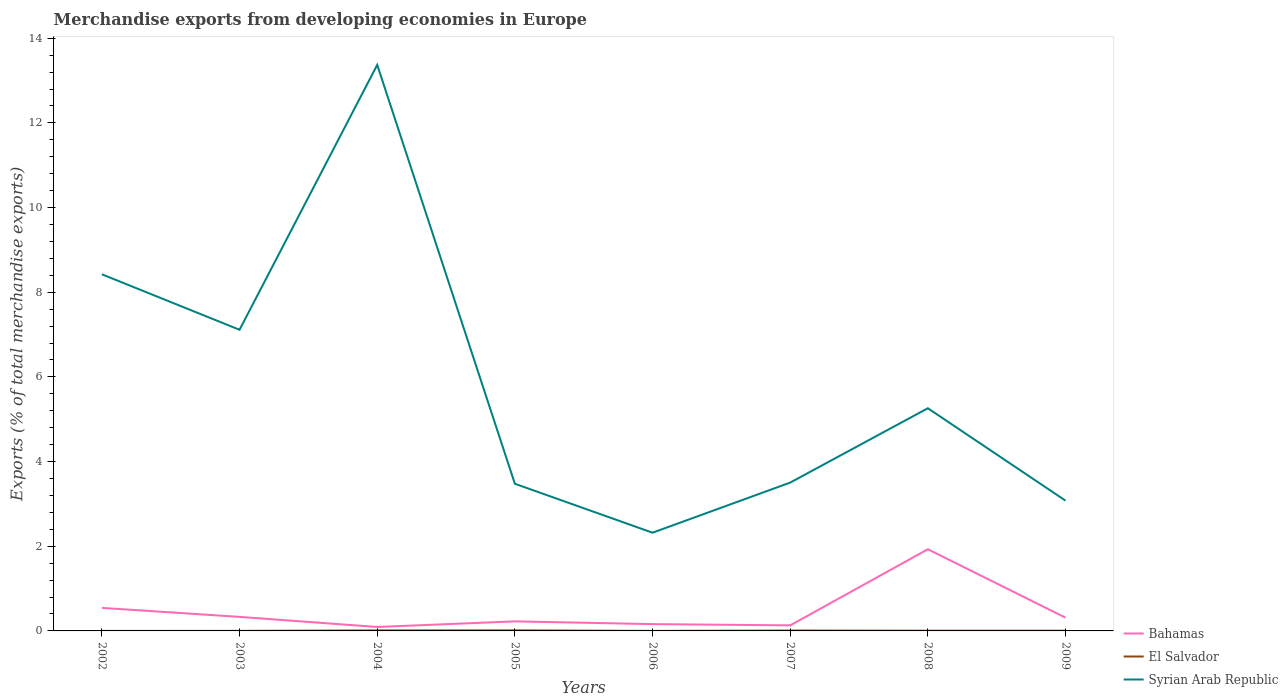How many different coloured lines are there?
Provide a succinct answer. 3. Does the line corresponding to Bahamas intersect with the line corresponding to Syrian Arab Republic?
Provide a short and direct response. No. Across all years, what is the maximum percentage of total merchandise exports in El Salvador?
Ensure brevity in your answer.  0. In which year was the percentage of total merchandise exports in Syrian Arab Republic maximum?
Your answer should be very brief. 2006. What is the total percentage of total merchandise exports in Syrian Arab Republic in the graph?
Keep it short and to the point. -1.78. What is the difference between the highest and the second highest percentage of total merchandise exports in Syrian Arab Republic?
Keep it short and to the point. 11.05. What is the difference between the highest and the lowest percentage of total merchandise exports in Bahamas?
Give a very brief answer. 2. Is the percentage of total merchandise exports in Syrian Arab Republic strictly greater than the percentage of total merchandise exports in Bahamas over the years?
Offer a terse response. No. How many years are there in the graph?
Keep it short and to the point. 8. Does the graph contain any zero values?
Offer a terse response. No. What is the title of the graph?
Make the answer very short. Merchandise exports from developing economies in Europe. Does "Middle East & North Africa (all income levels)" appear as one of the legend labels in the graph?
Give a very brief answer. No. What is the label or title of the Y-axis?
Give a very brief answer. Exports (% of total merchandise exports). What is the Exports (% of total merchandise exports) of Bahamas in 2002?
Your response must be concise. 0.54. What is the Exports (% of total merchandise exports) of El Salvador in 2002?
Your response must be concise. 0. What is the Exports (% of total merchandise exports) of Syrian Arab Republic in 2002?
Your answer should be very brief. 8.42. What is the Exports (% of total merchandise exports) in Bahamas in 2003?
Your response must be concise. 0.33. What is the Exports (% of total merchandise exports) of El Salvador in 2003?
Provide a short and direct response. 0. What is the Exports (% of total merchandise exports) of Syrian Arab Republic in 2003?
Provide a short and direct response. 7.11. What is the Exports (% of total merchandise exports) in Bahamas in 2004?
Keep it short and to the point. 0.09. What is the Exports (% of total merchandise exports) of El Salvador in 2004?
Your answer should be compact. 0.01. What is the Exports (% of total merchandise exports) of Syrian Arab Republic in 2004?
Provide a short and direct response. 13.37. What is the Exports (% of total merchandise exports) of Bahamas in 2005?
Your answer should be compact. 0.23. What is the Exports (% of total merchandise exports) in El Salvador in 2005?
Provide a short and direct response. 0.01. What is the Exports (% of total merchandise exports) of Syrian Arab Republic in 2005?
Offer a terse response. 3.48. What is the Exports (% of total merchandise exports) of Bahamas in 2006?
Keep it short and to the point. 0.16. What is the Exports (% of total merchandise exports) of El Salvador in 2006?
Provide a succinct answer. 0. What is the Exports (% of total merchandise exports) in Syrian Arab Republic in 2006?
Your answer should be compact. 2.32. What is the Exports (% of total merchandise exports) of Bahamas in 2007?
Keep it short and to the point. 0.13. What is the Exports (% of total merchandise exports) of El Salvador in 2007?
Offer a terse response. 0.01. What is the Exports (% of total merchandise exports) in Syrian Arab Republic in 2007?
Give a very brief answer. 3.5. What is the Exports (% of total merchandise exports) of Bahamas in 2008?
Make the answer very short. 1.93. What is the Exports (% of total merchandise exports) of El Salvador in 2008?
Offer a very short reply. 0. What is the Exports (% of total merchandise exports) of Syrian Arab Republic in 2008?
Offer a terse response. 5.26. What is the Exports (% of total merchandise exports) of Bahamas in 2009?
Keep it short and to the point. 0.31. What is the Exports (% of total merchandise exports) of El Salvador in 2009?
Your response must be concise. 0. What is the Exports (% of total merchandise exports) in Syrian Arab Republic in 2009?
Your answer should be very brief. 3.08. Across all years, what is the maximum Exports (% of total merchandise exports) in Bahamas?
Offer a very short reply. 1.93. Across all years, what is the maximum Exports (% of total merchandise exports) of El Salvador?
Offer a terse response. 0.01. Across all years, what is the maximum Exports (% of total merchandise exports) in Syrian Arab Republic?
Ensure brevity in your answer.  13.37. Across all years, what is the minimum Exports (% of total merchandise exports) in Bahamas?
Provide a succinct answer. 0.09. Across all years, what is the minimum Exports (% of total merchandise exports) of El Salvador?
Offer a very short reply. 0. Across all years, what is the minimum Exports (% of total merchandise exports) of Syrian Arab Republic?
Ensure brevity in your answer.  2.32. What is the total Exports (% of total merchandise exports) of Bahamas in the graph?
Keep it short and to the point. 3.73. What is the total Exports (% of total merchandise exports) of El Salvador in the graph?
Provide a succinct answer. 0.05. What is the total Exports (% of total merchandise exports) of Syrian Arab Republic in the graph?
Your answer should be compact. 46.55. What is the difference between the Exports (% of total merchandise exports) of Bahamas in 2002 and that in 2003?
Your response must be concise. 0.21. What is the difference between the Exports (% of total merchandise exports) in El Salvador in 2002 and that in 2003?
Provide a short and direct response. -0. What is the difference between the Exports (% of total merchandise exports) of Syrian Arab Republic in 2002 and that in 2003?
Provide a succinct answer. 1.31. What is the difference between the Exports (% of total merchandise exports) of Bahamas in 2002 and that in 2004?
Provide a short and direct response. 0.45. What is the difference between the Exports (% of total merchandise exports) of El Salvador in 2002 and that in 2004?
Make the answer very short. -0.01. What is the difference between the Exports (% of total merchandise exports) of Syrian Arab Republic in 2002 and that in 2004?
Keep it short and to the point. -4.95. What is the difference between the Exports (% of total merchandise exports) of Bahamas in 2002 and that in 2005?
Offer a terse response. 0.32. What is the difference between the Exports (% of total merchandise exports) of El Salvador in 2002 and that in 2005?
Provide a succinct answer. -0.01. What is the difference between the Exports (% of total merchandise exports) of Syrian Arab Republic in 2002 and that in 2005?
Your response must be concise. 4.95. What is the difference between the Exports (% of total merchandise exports) in Bahamas in 2002 and that in 2006?
Offer a very short reply. 0.38. What is the difference between the Exports (% of total merchandise exports) of Syrian Arab Republic in 2002 and that in 2006?
Your response must be concise. 6.1. What is the difference between the Exports (% of total merchandise exports) of Bahamas in 2002 and that in 2007?
Ensure brevity in your answer.  0.41. What is the difference between the Exports (% of total merchandise exports) of El Salvador in 2002 and that in 2007?
Ensure brevity in your answer.  -0.01. What is the difference between the Exports (% of total merchandise exports) in Syrian Arab Republic in 2002 and that in 2007?
Give a very brief answer. 4.92. What is the difference between the Exports (% of total merchandise exports) of Bahamas in 2002 and that in 2008?
Ensure brevity in your answer.  -1.38. What is the difference between the Exports (% of total merchandise exports) in El Salvador in 2002 and that in 2008?
Provide a succinct answer. -0. What is the difference between the Exports (% of total merchandise exports) in Syrian Arab Republic in 2002 and that in 2008?
Your answer should be very brief. 3.16. What is the difference between the Exports (% of total merchandise exports) in Bahamas in 2002 and that in 2009?
Your answer should be very brief. 0.23. What is the difference between the Exports (% of total merchandise exports) in El Salvador in 2002 and that in 2009?
Ensure brevity in your answer.  -0. What is the difference between the Exports (% of total merchandise exports) of Syrian Arab Republic in 2002 and that in 2009?
Your response must be concise. 5.35. What is the difference between the Exports (% of total merchandise exports) of Bahamas in 2003 and that in 2004?
Provide a succinct answer. 0.24. What is the difference between the Exports (% of total merchandise exports) in El Salvador in 2003 and that in 2004?
Give a very brief answer. -0.01. What is the difference between the Exports (% of total merchandise exports) of Syrian Arab Republic in 2003 and that in 2004?
Provide a succinct answer. -6.26. What is the difference between the Exports (% of total merchandise exports) of Bahamas in 2003 and that in 2005?
Ensure brevity in your answer.  0.11. What is the difference between the Exports (% of total merchandise exports) of El Salvador in 2003 and that in 2005?
Your answer should be very brief. -0.01. What is the difference between the Exports (% of total merchandise exports) of Syrian Arab Republic in 2003 and that in 2005?
Provide a succinct answer. 3.64. What is the difference between the Exports (% of total merchandise exports) in Bahamas in 2003 and that in 2006?
Give a very brief answer. 0.17. What is the difference between the Exports (% of total merchandise exports) in El Salvador in 2003 and that in 2006?
Make the answer very short. 0. What is the difference between the Exports (% of total merchandise exports) of Syrian Arab Republic in 2003 and that in 2006?
Make the answer very short. 4.79. What is the difference between the Exports (% of total merchandise exports) of Bahamas in 2003 and that in 2007?
Provide a succinct answer. 0.2. What is the difference between the Exports (% of total merchandise exports) in El Salvador in 2003 and that in 2007?
Your answer should be compact. -0.01. What is the difference between the Exports (% of total merchandise exports) of Syrian Arab Republic in 2003 and that in 2007?
Keep it short and to the point. 3.61. What is the difference between the Exports (% of total merchandise exports) in Bahamas in 2003 and that in 2008?
Your answer should be compact. -1.6. What is the difference between the Exports (% of total merchandise exports) of El Salvador in 2003 and that in 2008?
Provide a short and direct response. -0. What is the difference between the Exports (% of total merchandise exports) in Syrian Arab Republic in 2003 and that in 2008?
Your answer should be very brief. 1.85. What is the difference between the Exports (% of total merchandise exports) in Bahamas in 2003 and that in 2009?
Your answer should be very brief. 0.02. What is the difference between the Exports (% of total merchandise exports) of El Salvador in 2003 and that in 2009?
Provide a succinct answer. -0. What is the difference between the Exports (% of total merchandise exports) in Syrian Arab Republic in 2003 and that in 2009?
Provide a succinct answer. 4.04. What is the difference between the Exports (% of total merchandise exports) in Bahamas in 2004 and that in 2005?
Ensure brevity in your answer.  -0.13. What is the difference between the Exports (% of total merchandise exports) in El Salvador in 2004 and that in 2005?
Your answer should be very brief. -0. What is the difference between the Exports (% of total merchandise exports) in Syrian Arab Republic in 2004 and that in 2005?
Offer a very short reply. 9.89. What is the difference between the Exports (% of total merchandise exports) of Bahamas in 2004 and that in 2006?
Offer a terse response. -0.07. What is the difference between the Exports (% of total merchandise exports) of El Salvador in 2004 and that in 2006?
Provide a short and direct response. 0.01. What is the difference between the Exports (% of total merchandise exports) in Syrian Arab Republic in 2004 and that in 2006?
Provide a short and direct response. 11.05. What is the difference between the Exports (% of total merchandise exports) of Bahamas in 2004 and that in 2007?
Make the answer very short. -0.04. What is the difference between the Exports (% of total merchandise exports) of El Salvador in 2004 and that in 2007?
Your answer should be compact. 0. What is the difference between the Exports (% of total merchandise exports) in Syrian Arab Republic in 2004 and that in 2007?
Give a very brief answer. 9.87. What is the difference between the Exports (% of total merchandise exports) in Bahamas in 2004 and that in 2008?
Give a very brief answer. -1.84. What is the difference between the Exports (% of total merchandise exports) of El Salvador in 2004 and that in 2008?
Keep it short and to the point. 0.01. What is the difference between the Exports (% of total merchandise exports) of Syrian Arab Republic in 2004 and that in 2008?
Your answer should be very brief. 8.11. What is the difference between the Exports (% of total merchandise exports) of Bahamas in 2004 and that in 2009?
Offer a terse response. -0.22. What is the difference between the Exports (% of total merchandise exports) of El Salvador in 2004 and that in 2009?
Keep it short and to the point. 0.01. What is the difference between the Exports (% of total merchandise exports) in Syrian Arab Republic in 2004 and that in 2009?
Your response must be concise. 10.29. What is the difference between the Exports (% of total merchandise exports) in Bahamas in 2005 and that in 2006?
Your answer should be compact. 0.07. What is the difference between the Exports (% of total merchandise exports) of El Salvador in 2005 and that in 2006?
Keep it short and to the point. 0.01. What is the difference between the Exports (% of total merchandise exports) of Syrian Arab Republic in 2005 and that in 2006?
Ensure brevity in your answer.  1.16. What is the difference between the Exports (% of total merchandise exports) in Bahamas in 2005 and that in 2007?
Offer a terse response. 0.09. What is the difference between the Exports (% of total merchandise exports) of El Salvador in 2005 and that in 2007?
Your answer should be very brief. 0. What is the difference between the Exports (% of total merchandise exports) in Syrian Arab Republic in 2005 and that in 2007?
Keep it short and to the point. -0.03. What is the difference between the Exports (% of total merchandise exports) in Bahamas in 2005 and that in 2008?
Ensure brevity in your answer.  -1.7. What is the difference between the Exports (% of total merchandise exports) in El Salvador in 2005 and that in 2008?
Offer a terse response. 0.01. What is the difference between the Exports (% of total merchandise exports) of Syrian Arab Republic in 2005 and that in 2008?
Your answer should be compact. -1.78. What is the difference between the Exports (% of total merchandise exports) of Bahamas in 2005 and that in 2009?
Your answer should be compact. -0.09. What is the difference between the Exports (% of total merchandise exports) of El Salvador in 2005 and that in 2009?
Keep it short and to the point. 0.01. What is the difference between the Exports (% of total merchandise exports) of Syrian Arab Republic in 2005 and that in 2009?
Give a very brief answer. 0.4. What is the difference between the Exports (% of total merchandise exports) of Bahamas in 2006 and that in 2007?
Your answer should be very brief. 0.03. What is the difference between the Exports (% of total merchandise exports) of El Salvador in 2006 and that in 2007?
Your response must be concise. -0.01. What is the difference between the Exports (% of total merchandise exports) in Syrian Arab Republic in 2006 and that in 2007?
Provide a succinct answer. -1.18. What is the difference between the Exports (% of total merchandise exports) in Bahamas in 2006 and that in 2008?
Give a very brief answer. -1.77. What is the difference between the Exports (% of total merchandise exports) in El Salvador in 2006 and that in 2008?
Your answer should be very brief. -0. What is the difference between the Exports (% of total merchandise exports) in Syrian Arab Republic in 2006 and that in 2008?
Provide a short and direct response. -2.94. What is the difference between the Exports (% of total merchandise exports) in Bahamas in 2006 and that in 2009?
Provide a succinct answer. -0.15. What is the difference between the Exports (% of total merchandise exports) in El Salvador in 2006 and that in 2009?
Offer a terse response. -0. What is the difference between the Exports (% of total merchandise exports) in Syrian Arab Republic in 2006 and that in 2009?
Provide a short and direct response. -0.76. What is the difference between the Exports (% of total merchandise exports) in Bahamas in 2007 and that in 2008?
Keep it short and to the point. -1.8. What is the difference between the Exports (% of total merchandise exports) in El Salvador in 2007 and that in 2008?
Your response must be concise. 0. What is the difference between the Exports (% of total merchandise exports) in Syrian Arab Republic in 2007 and that in 2008?
Your answer should be very brief. -1.76. What is the difference between the Exports (% of total merchandise exports) of Bahamas in 2007 and that in 2009?
Provide a succinct answer. -0.18. What is the difference between the Exports (% of total merchandise exports) of El Salvador in 2007 and that in 2009?
Keep it short and to the point. 0. What is the difference between the Exports (% of total merchandise exports) in Syrian Arab Republic in 2007 and that in 2009?
Give a very brief answer. 0.43. What is the difference between the Exports (% of total merchandise exports) in Bahamas in 2008 and that in 2009?
Ensure brevity in your answer.  1.62. What is the difference between the Exports (% of total merchandise exports) of Syrian Arab Republic in 2008 and that in 2009?
Offer a terse response. 2.18. What is the difference between the Exports (% of total merchandise exports) of Bahamas in 2002 and the Exports (% of total merchandise exports) of El Salvador in 2003?
Your answer should be very brief. 0.54. What is the difference between the Exports (% of total merchandise exports) of Bahamas in 2002 and the Exports (% of total merchandise exports) of Syrian Arab Republic in 2003?
Your response must be concise. -6.57. What is the difference between the Exports (% of total merchandise exports) in El Salvador in 2002 and the Exports (% of total merchandise exports) in Syrian Arab Republic in 2003?
Offer a very short reply. -7.11. What is the difference between the Exports (% of total merchandise exports) in Bahamas in 2002 and the Exports (% of total merchandise exports) in El Salvador in 2004?
Your answer should be very brief. 0.53. What is the difference between the Exports (% of total merchandise exports) of Bahamas in 2002 and the Exports (% of total merchandise exports) of Syrian Arab Republic in 2004?
Make the answer very short. -12.83. What is the difference between the Exports (% of total merchandise exports) in El Salvador in 2002 and the Exports (% of total merchandise exports) in Syrian Arab Republic in 2004?
Give a very brief answer. -13.37. What is the difference between the Exports (% of total merchandise exports) of Bahamas in 2002 and the Exports (% of total merchandise exports) of El Salvador in 2005?
Offer a very short reply. 0.53. What is the difference between the Exports (% of total merchandise exports) in Bahamas in 2002 and the Exports (% of total merchandise exports) in Syrian Arab Republic in 2005?
Provide a succinct answer. -2.93. What is the difference between the Exports (% of total merchandise exports) of El Salvador in 2002 and the Exports (% of total merchandise exports) of Syrian Arab Republic in 2005?
Your answer should be compact. -3.48. What is the difference between the Exports (% of total merchandise exports) in Bahamas in 2002 and the Exports (% of total merchandise exports) in El Salvador in 2006?
Keep it short and to the point. 0.54. What is the difference between the Exports (% of total merchandise exports) of Bahamas in 2002 and the Exports (% of total merchandise exports) of Syrian Arab Republic in 2006?
Keep it short and to the point. -1.78. What is the difference between the Exports (% of total merchandise exports) of El Salvador in 2002 and the Exports (% of total merchandise exports) of Syrian Arab Republic in 2006?
Keep it short and to the point. -2.32. What is the difference between the Exports (% of total merchandise exports) in Bahamas in 2002 and the Exports (% of total merchandise exports) in El Salvador in 2007?
Offer a terse response. 0.54. What is the difference between the Exports (% of total merchandise exports) of Bahamas in 2002 and the Exports (% of total merchandise exports) of Syrian Arab Republic in 2007?
Offer a terse response. -2.96. What is the difference between the Exports (% of total merchandise exports) of El Salvador in 2002 and the Exports (% of total merchandise exports) of Syrian Arab Republic in 2007?
Provide a short and direct response. -3.5. What is the difference between the Exports (% of total merchandise exports) in Bahamas in 2002 and the Exports (% of total merchandise exports) in El Salvador in 2008?
Keep it short and to the point. 0.54. What is the difference between the Exports (% of total merchandise exports) in Bahamas in 2002 and the Exports (% of total merchandise exports) in Syrian Arab Republic in 2008?
Provide a succinct answer. -4.72. What is the difference between the Exports (% of total merchandise exports) of El Salvador in 2002 and the Exports (% of total merchandise exports) of Syrian Arab Republic in 2008?
Offer a very short reply. -5.26. What is the difference between the Exports (% of total merchandise exports) in Bahamas in 2002 and the Exports (% of total merchandise exports) in El Salvador in 2009?
Provide a short and direct response. 0.54. What is the difference between the Exports (% of total merchandise exports) of Bahamas in 2002 and the Exports (% of total merchandise exports) of Syrian Arab Republic in 2009?
Give a very brief answer. -2.53. What is the difference between the Exports (% of total merchandise exports) of El Salvador in 2002 and the Exports (% of total merchandise exports) of Syrian Arab Republic in 2009?
Make the answer very short. -3.08. What is the difference between the Exports (% of total merchandise exports) of Bahamas in 2003 and the Exports (% of total merchandise exports) of El Salvador in 2004?
Provide a succinct answer. 0.32. What is the difference between the Exports (% of total merchandise exports) of Bahamas in 2003 and the Exports (% of total merchandise exports) of Syrian Arab Republic in 2004?
Ensure brevity in your answer.  -13.04. What is the difference between the Exports (% of total merchandise exports) in El Salvador in 2003 and the Exports (% of total merchandise exports) in Syrian Arab Republic in 2004?
Offer a terse response. -13.37. What is the difference between the Exports (% of total merchandise exports) in Bahamas in 2003 and the Exports (% of total merchandise exports) in El Salvador in 2005?
Provide a short and direct response. 0.32. What is the difference between the Exports (% of total merchandise exports) of Bahamas in 2003 and the Exports (% of total merchandise exports) of Syrian Arab Republic in 2005?
Provide a short and direct response. -3.14. What is the difference between the Exports (% of total merchandise exports) in El Salvador in 2003 and the Exports (% of total merchandise exports) in Syrian Arab Republic in 2005?
Ensure brevity in your answer.  -3.48. What is the difference between the Exports (% of total merchandise exports) in Bahamas in 2003 and the Exports (% of total merchandise exports) in El Salvador in 2006?
Ensure brevity in your answer.  0.33. What is the difference between the Exports (% of total merchandise exports) of Bahamas in 2003 and the Exports (% of total merchandise exports) of Syrian Arab Republic in 2006?
Provide a succinct answer. -1.99. What is the difference between the Exports (% of total merchandise exports) of El Salvador in 2003 and the Exports (% of total merchandise exports) of Syrian Arab Republic in 2006?
Ensure brevity in your answer.  -2.32. What is the difference between the Exports (% of total merchandise exports) in Bahamas in 2003 and the Exports (% of total merchandise exports) in El Salvador in 2007?
Offer a very short reply. 0.32. What is the difference between the Exports (% of total merchandise exports) of Bahamas in 2003 and the Exports (% of total merchandise exports) of Syrian Arab Republic in 2007?
Offer a terse response. -3.17. What is the difference between the Exports (% of total merchandise exports) in El Salvador in 2003 and the Exports (% of total merchandise exports) in Syrian Arab Republic in 2007?
Give a very brief answer. -3.5. What is the difference between the Exports (% of total merchandise exports) of Bahamas in 2003 and the Exports (% of total merchandise exports) of El Salvador in 2008?
Provide a short and direct response. 0.33. What is the difference between the Exports (% of total merchandise exports) in Bahamas in 2003 and the Exports (% of total merchandise exports) in Syrian Arab Republic in 2008?
Your answer should be very brief. -4.93. What is the difference between the Exports (% of total merchandise exports) of El Salvador in 2003 and the Exports (% of total merchandise exports) of Syrian Arab Republic in 2008?
Provide a short and direct response. -5.26. What is the difference between the Exports (% of total merchandise exports) in Bahamas in 2003 and the Exports (% of total merchandise exports) in El Salvador in 2009?
Make the answer very short. 0.33. What is the difference between the Exports (% of total merchandise exports) in Bahamas in 2003 and the Exports (% of total merchandise exports) in Syrian Arab Republic in 2009?
Your answer should be very brief. -2.75. What is the difference between the Exports (% of total merchandise exports) of El Salvador in 2003 and the Exports (% of total merchandise exports) of Syrian Arab Republic in 2009?
Your response must be concise. -3.08. What is the difference between the Exports (% of total merchandise exports) in Bahamas in 2004 and the Exports (% of total merchandise exports) in El Salvador in 2005?
Offer a terse response. 0.08. What is the difference between the Exports (% of total merchandise exports) in Bahamas in 2004 and the Exports (% of total merchandise exports) in Syrian Arab Republic in 2005?
Offer a terse response. -3.38. What is the difference between the Exports (% of total merchandise exports) of El Salvador in 2004 and the Exports (% of total merchandise exports) of Syrian Arab Republic in 2005?
Make the answer very short. -3.46. What is the difference between the Exports (% of total merchandise exports) in Bahamas in 2004 and the Exports (% of total merchandise exports) in El Salvador in 2006?
Offer a very short reply. 0.09. What is the difference between the Exports (% of total merchandise exports) in Bahamas in 2004 and the Exports (% of total merchandise exports) in Syrian Arab Republic in 2006?
Keep it short and to the point. -2.23. What is the difference between the Exports (% of total merchandise exports) of El Salvador in 2004 and the Exports (% of total merchandise exports) of Syrian Arab Republic in 2006?
Your answer should be very brief. -2.31. What is the difference between the Exports (% of total merchandise exports) in Bahamas in 2004 and the Exports (% of total merchandise exports) in El Salvador in 2007?
Offer a very short reply. 0.08. What is the difference between the Exports (% of total merchandise exports) in Bahamas in 2004 and the Exports (% of total merchandise exports) in Syrian Arab Republic in 2007?
Offer a very short reply. -3.41. What is the difference between the Exports (% of total merchandise exports) in El Salvador in 2004 and the Exports (% of total merchandise exports) in Syrian Arab Republic in 2007?
Give a very brief answer. -3.49. What is the difference between the Exports (% of total merchandise exports) in Bahamas in 2004 and the Exports (% of total merchandise exports) in El Salvador in 2008?
Make the answer very short. 0.09. What is the difference between the Exports (% of total merchandise exports) of Bahamas in 2004 and the Exports (% of total merchandise exports) of Syrian Arab Republic in 2008?
Provide a succinct answer. -5.17. What is the difference between the Exports (% of total merchandise exports) in El Salvador in 2004 and the Exports (% of total merchandise exports) in Syrian Arab Republic in 2008?
Provide a short and direct response. -5.25. What is the difference between the Exports (% of total merchandise exports) in Bahamas in 2004 and the Exports (% of total merchandise exports) in El Salvador in 2009?
Ensure brevity in your answer.  0.09. What is the difference between the Exports (% of total merchandise exports) in Bahamas in 2004 and the Exports (% of total merchandise exports) in Syrian Arab Republic in 2009?
Offer a very short reply. -2.98. What is the difference between the Exports (% of total merchandise exports) in El Salvador in 2004 and the Exports (% of total merchandise exports) in Syrian Arab Republic in 2009?
Provide a succinct answer. -3.07. What is the difference between the Exports (% of total merchandise exports) of Bahamas in 2005 and the Exports (% of total merchandise exports) of El Salvador in 2006?
Your answer should be compact. 0.23. What is the difference between the Exports (% of total merchandise exports) in Bahamas in 2005 and the Exports (% of total merchandise exports) in Syrian Arab Republic in 2006?
Ensure brevity in your answer.  -2.09. What is the difference between the Exports (% of total merchandise exports) of El Salvador in 2005 and the Exports (% of total merchandise exports) of Syrian Arab Republic in 2006?
Provide a short and direct response. -2.31. What is the difference between the Exports (% of total merchandise exports) in Bahamas in 2005 and the Exports (% of total merchandise exports) in El Salvador in 2007?
Provide a succinct answer. 0.22. What is the difference between the Exports (% of total merchandise exports) in Bahamas in 2005 and the Exports (% of total merchandise exports) in Syrian Arab Republic in 2007?
Offer a very short reply. -3.28. What is the difference between the Exports (% of total merchandise exports) in El Salvador in 2005 and the Exports (% of total merchandise exports) in Syrian Arab Republic in 2007?
Offer a terse response. -3.49. What is the difference between the Exports (% of total merchandise exports) of Bahamas in 2005 and the Exports (% of total merchandise exports) of El Salvador in 2008?
Ensure brevity in your answer.  0.22. What is the difference between the Exports (% of total merchandise exports) of Bahamas in 2005 and the Exports (% of total merchandise exports) of Syrian Arab Republic in 2008?
Give a very brief answer. -5.03. What is the difference between the Exports (% of total merchandise exports) of El Salvador in 2005 and the Exports (% of total merchandise exports) of Syrian Arab Republic in 2008?
Make the answer very short. -5.25. What is the difference between the Exports (% of total merchandise exports) in Bahamas in 2005 and the Exports (% of total merchandise exports) in El Salvador in 2009?
Ensure brevity in your answer.  0.22. What is the difference between the Exports (% of total merchandise exports) of Bahamas in 2005 and the Exports (% of total merchandise exports) of Syrian Arab Republic in 2009?
Provide a succinct answer. -2.85. What is the difference between the Exports (% of total merchandise exports) in El Salvador in 2005 and the Exports (% of total merchandise exports) in Syrian Arab Republic in 2009?
Give a very brief answer. -3.06. What is the difference between the Exports (% of total merchandise exports) of Bahamas in 2006 and the Exports (% of total merchandise exports) of El Salvador in 2007?
Provide a short and direct response. 0.15. What is the difference between the Exports (% of total merchandise exports) in Bahamas in 2006 and the Exports (% of total merchandise exports) in Syrian Arab Republic in 2007?
Offer a terse response. -3.34. What is the difference between the Exports (% of total merchandise exports) of El Salvador in 2006 and the Exports (% of total merchandise exports) of Syrian Arab Republic in 2007?
Provide a short and direct response. -3.5. What is the difference between the Exports (% of total merchandise exports) in Bahamas in 2006 and the Exports (% of total merchandise exports) in El Salvador in 2008?
Provide a short and direct response. 0.16. What is the difference between the Exports (% of total merchandise exports) in Bahamas in 2006 and the Exports (% of total merchandise exports) in Syrian Arab Republic in 2008?
Offer a very short reply. -5.1. What is the difference between the Exports (% of total merchandise exports) in El Salvador in 2006 and the Exports (% of total merchandise exports) in Syrian Arab Republic in 2008?
Ensure brevity in your answer.  -5.26. What is the difference between the Exports (% of total merchandise exports) in Bahamas in 2006 and the Exports (% of total merchandise exports) in El Salvador in 2009?
Provide a short and direct response. 0.16. What is the difference between the Exports (% of total merchandise exports) in Bahamas in 2006 and the Exports (% of total merchandise exports) in Syrian Arab Republic in 2009?
Offer a very short reply. -2.92. What is the difference between the Exports (% of total merchandise exports) in El Salvador in 2006 and the Exports (% of total merchandise exports) in Syrian Arab Republic in 2009?
Make the answer very short. -3.08. What is the difference between the Exports (% of total merchandise exports) of Bahamas in 2007 and the Exports (% of total merchandise exports) of El Salvador in 2008?
Offer a terse response. 0.13. What is the difference between the Exports (% of total merchandise exports) of Bahamas in 2007 and the Exports (% of total merchandise exports) of Syrian Arab Republic in 2008?
Your answer should be very brief. -5.13. What is the difference between the Exports (% of total merchandise exports) in El Salvador in 2007 and the Exports (% of total merchandise exports) in Syrian Arab Republic in 2008?
Make the answer very short. -5.25. What is the difference between the Exports (% of total merchandise exports) in Bahamas in 2007 and the Exports (% of total merchandise exports) in El Salvador in 2009?
Keep it short and to the point. 0.13. What is the difference between the Exports (% of total merchandise exports) in Bahamas in 2007 and the Exports (% of total merchandise exports) in Syrian Arab Republic in 2009?
Offer a terse response. -2.95. What is the difference between the Exports (% of total merchandise exports) of El Salvador in 2007 and the Exports (% of total merchandise exports) of Syrian Arab Republic in 2009?
Offer a terse response. -3.07. What is the difference between the Exports (% of total merchandise exports) in Bahamas in 2008 and the Exports (% of total merchandise exports) in El Salvador in 2009?
Your answer should be compact. 1.92. What is the difference between the Exports (% of total merchandise exports) of Bahamas in 2008 and the Exports (% of total merchandise exports) of Syrian Arab Republic in 2009?
Your answer should be very brief. -1.15. What is the difference between the Exports (% of total merchandise exports) of El Salvador in 2008 and the Exports (% of total merchandise exports) of Syrian Arab Republic in 2009?
Give a very brief answer. -3.07. What is the average Exports (% of total merchandise exports) of Bahamas per year?
Ensure brevity in your answer.  0.47. What is the average Exports (% of total merchandise exports) of El Salvador per year?
Your answer should be very brief. 0.01. What is the average Exports (% of total merchandise exports) of Syrian Arab Republic per year?
Your answer should be compact. 5.82. In the year 2002, what is the difference between the Exports (% of total merchandise exports) in Bahamas and Exports (% of total merchandise exports) in El Salvador?
Provide a short and direct response. 0.54. In the year 2002, what is the difference between the Exports (% of total merchandise exports) in Bahamas and Exports (% of total merchandise exports) in Syrian Arab Republic?
Make the answer very short. -7.88. In the year 2002, what is the difference between the Exports (% of total merchandise exports) of El Salvador and Exports (% of total merchandise exports) of Syrian Arab Republic?
Your answer should be very brief. -8.42. In the year 2003, what is the difference between the Exports (% of total merchandise exports) in Bahamas and Exports (% of total merchandise exports) in El Salvador?
Offer a terse response. 0.33. In the year 2003, what is the difference between the Exports (% of total merchandise exports) of Bahamas and Exports (% of total merchandise exports) of Syrian Arab Republic?
Provide a short and direct response. -6.78. In the year 2003, what is the difference between the Exports (% of total merchandise exports) of El Salvador and Exports (% of total merchandise exports) of Syrian Arab Republic?
Offer a very short reply. -7.11. In the year 2004, what is the difference between the Exports (% of total merchandise exports) of Bahamas and Exports (% of total merchandise exports) of El Salvador?
Keep it short and to the point. 0.08. In the year 2004, what is the difference between the Exports (% of total merchandise exports) of Bahamas and Exports (% of total merchandise exports) of Syrian Arab Republic?
Ensure brevity in your answer.  -13.28. In the year 2004, what is the difference between the Exports (% of total merchandise exports) in El Salvador and Exports (% of total merchandise exports) in Syrian Arab Republic?
Give a very brief answer. -13.36. In the year 2005, what is the difference between the Exports (% of total merchandise exports) of Bahamas and Exports (% of total merchandise exports) of El Salvador?
Ensure brevity in your answer.  0.21. In the year 2005, what is the difference between the Exports (% of total merchandise exports) of Bahamas and Exports (% of total merchandise exports) of Syrian Arab Republic?
Offer a very short reply. -3.25. In the year 2005, what is the difference between the Exports (% of total merchandise exports) of El Salvador and Exports (% of total merchandise exports) of Syrian Arab Republic?
Provide a succinct answer. -3.46. In the year 2006, what is the difference between the Exports (% of total merchandise exports) of Bahamas and Exports (% of total merchandise exports) of El Salvador?
Ensure brevity in your answer.  0.16. In the year 2006, what is the difference between the Exports (% of total merchandise exports) of Bahamas and Exports (% of total merchandise exports) of Syrian Arab Republic?
Offer a terse response. -2.16. In the year 2006, what is the difference between the Exports (% of total merchandise exports) of El Salvador and Exports (% of total merchandise exports) of Syrian Arab Republic?
Give a very brief answer. -2.32. In the year 2007, what is the difference between the Exports (% of total merchandise exports) of Bahamas and Exports (% of total merchandise exports) of El Salvador?
Give a very brief answer. 0.12. In the year 2007, what is the difference between the Exports (% of total merchandise exports) in Bahamas and Exports (% of total merchandise exports) in Syrian Arab Republic?
Make the answer very short. -3.37. In the year 2007, what is the difference between the Exports (% of total merchandise exports) of El Salvador and Exports (% of total merchandise exports) of Syrian Arab Republic?
Ensure brevity in your answer.  -3.49. In the year 2008, what is the difference between the Exports (% of total merchandise exports) of Bahamas and Exports (% of total merchandise exports) of El Salvador?
Your answer should be compact. 1.92. In the year 2008, what is the difference between the Exports (% of total merchandise exports) of Bahamas and Exports (% of total merchandise exports) of Syrian Arab Republic?
Provide a short and direct response. -3.33. In the year 2008, what is the difference between the Exports (% of total merchandise exports) in El Salvador and Exports (% of total merchandise exports) in Syrian Arab Republic?
Your answer should be very brief. -5.25. In the year 2009, what is the difference between the Exports (% of total merchandise exports) in Bahamas and Exports (% of total merchandise exports) in El Salvador?
Provide a succinct answer. 0.31. In the year 2009, what is the difference between the Exports (% of total merchandise exports) in Bahamas and Exports (% of total merchandise exports) in Syrian Arab Republic?
Give a very brief answer. -2.76. In the year 2009, what is the difference between the Exports (% of total merchandise exports) in El Salvador and Exports (% of total merchandise exports) in Syrian Arab Republic?
Give a very brief answer. -3.07. What is the ratio of the Exports (% of total merchandise exports) in Bahamas in 2002 to that in 2003?
Make the answer very short. 1.64. What is the ratio of the Exports (% of total merchandise exports) in El Salvador in 2002 to that in 2003?
Your answer should be very brief. 0.71. What is the ratio of the Exports (% of total merchandise exports) of Syrian Arab Republic in 2002 to that in 2003?
Give a very brief answer. 1.18. What is the ratio of the Exports (% of total merchandise exports) of Bahamas in 2002 to that in 2004?
Make the answer very short. 5.83. What is the ratio of the Exports (% of total merchandise exports) of El Salvador in 2002 to that in 2004?
Ensure brevity in your answer.  0.07. What is the ratio of the Exports (% of total merchandise exports) in Syrian Arab Republic in 2002 to that in 2004?
Your answer should be very brief. 0.63. What is the ratio of the Exports (% of total merchandise exports) of Bahamas in 2002 to that in 2005?
Offer a very short reply. 2.41. What is the ratio of the Exports (% of total merchandise exports) in El Salvador in 2002 to that in 2005?
Ensure brevity in your answer.  0.06. What is the ratio of the Exports (% of total merchandise exports) in Syrian Arab Republic in 2002 to that in 2005?
Provide a short and direct response. 2.42. What is the ratio of the Exports (% of total merchandise exports) of Bahamas in 2002 to that in 2006?
Make the answer very short. 3.38. What is the ratio of the Exports (% of total merchandise exports) in El Salvador in 2002 to that in 2006?
Provide a succinct answer. 1.63. What is the ratio of the Exports (% of total merchandise exports) of Syrian Arab Republic in 2002 to that in 2006?
Offer a very short reply. 3.63. What is the ratio of the Exports (% of total merchandise exports) in Bahamas in 2002 to that in 2007?
Make the answer very short. 4.15. What is the ratio of the Exports (% of total merchandise exports) of El Salvador in 2002 to that in 2007?
Give a very brief answer. 0.09. What is the ratio of the Exports (% of total merchandise exports) in Syrian Arab Republic in 2002 to that in 2007?
Keep it short and to the point. 2.4. What is the ratio of the Exports (% of total merchandise exports) of Bahamas in 2002 to that in 2008?
Your answer should be compact. 0.28. What is the ratio of the Exports (% of total merchandise exports) of El Salvador in 2002 to that in 2008?
Keep it short and to the point. 0.16. What is the ratio of the Exports (% of total merchandise exports) of Syrian Arab Republic in 2002 to that in 2008?
Ensure brevity in your answer.  1.6. What is the ratio of the Exports (% of total merchandise exports) in Bahamas in 2002 to that in 2009?
Provide a short and direct response. 1.74. What is the ratio of the Exports (% of total merchandise exports) of El Salvador in 2002 to that in 2009?
Give a very brief answer. 0.17. What is the ratio of the Exports (% of total merchandise exports) of Syrian Arab Republic in 2002 to that in 2009?
Provide a short and direct response. 2.74. What is the ratio of the Exports (% of total merchandise exports) in Bahamas in 2003 to that in 2004?
Provide a succinct answer. 3.55. What is the ratio of the Exports (% of total merchandise exports) of El Salvador in 2003 to that in 2004?
Your response must be concise. 0.1. What is the ratio of the Exports (% of total merchandise exports) in Syrian Arab Republic in 2003 to that in 2004?
Your response must be concise. 0.53. What is the ratio of the Exports (% of total merchandise exports) of Bahamas in 2003 to that in 2005?
Your answer should be compact. 1.47. What is the ratio of the Exports (% of total merchandise exports) of El Salvador in 2003 to that in 2005?
Your response must be concise. 0.09. What is the ratio of the Exports (% of total merchandise exports) in Syrian Arab Republic in 2003 to that in 2005?
Offer a terse response. 2.05. What is the ratio of the Exports (% of total merchandise exports) in Bahamas in 2003 to that in 2006?
Your answer should be very brief. 2.06. What is the ratio of the Exports (% of total merchandise exports) of El Salvador in 2003 to that in 2006?
Keep it short and to the point. 2.31. What is the ratio of the Exports (% of total merchandise exports) in Syrian Arab Republic in 2003 to that in 2006?
Provide a succinct answer. 3.07. What is the ratio of the Exports (% of total merchandise exports) in Bahamas in 2003 to that in 2007?
Give a very brief answer. 2.52. What is the ratio of the Exports (% of total merchandise exports) in El Salvador in 2003 to that in 2007?
Your answer should be very brief. 0.12. What is the ratio of the Exports (% of total merchandise exports) in Syrian Arab Republic in 2003 to that in 2007?
Make the answer very short. 2.03. What is the ratio of the Exports (% of total merchandise exports) in Bahamas in 2003 to that in 2008?
Provide a short and direct response. 0.17. What is the ratio of the Exports (% of total merchandise exports) of El Salvador in 2003 to that in 2008?
Keep it short and to the point. 0.23. What is the ratio of the Exports (% of total merchandise exports) of Syrian Arab Republic in 2003 to that in 2008?
Provide a short and direct response. 1.35. What is the ratio of the Exports (% of total merchandise exports) in Bahamas in 2003 to that in 2009?
Give a very brief answer. 1.06. What is the ratio of the Exports (% of total merchandise exports) of El Salvador in 2003 to that in 2009?
Your response must be concise. 0.24. What is the ratio of the Exports (% of total merchandise exports) of Syrian Arab Republic in 2003 to that in 2009?
Provide a short and direct response. 2.31. What is the ratio of the Exports (% of total merchandise exports) in Bahamas in 2004 to that in 2005?
Your answer should be very brief. 0.41. What is the ratio of the Exports (% of total merchandise exports) of El Salvador in 2004 to that in 2005?
Keep it short and to the point. 0.88. What is the ratio of the Exports (% of total merchandise exports) in Syrian Arab Republic in 2004 to that in 2005?
Your response must be concise. 3.85. What is the ratio of the Exports (% of total merchandise exports) of Bahamas in 2004 to that in 2006?
Give a very brief answer. 0.58. What is the ratio of the Exports (% of total merchandise exports) in El Salvador in 2004 to that in 2006?
Ensure brevity in your answer.  23.31. What is the ratio of the Exports (% of total merchandise exports) of Syrian Arab Republic in 2004 to that in 2006?
Make the answer very short. 5.76. What is the ratio of the Exports (% of total merchandise exports) in Bahamas in 2004 to that in 2007?
Ensure brevity in your answer.  0.71. What is the ratio of the Exports (% of total merchandise exports) of El Salvador in 2004 to that in 2007?
Ensure brevity in your answer.  1.26. What is the ratio of the Exports (% of total merchandise exports) of Syrian Arab Republic in 2004 to that in 2007?
Your response must be concise. 3.82. What is the ratio of the Exports (% of total merchandise exports) of Bahamas in 2004 to that in 2008?
Make the answer very short. 0.05. What is the ratio of the Exports (% of total merchandise exports) of El Salvador in 2004 to that in 2008?
Ensure brevity in your answer.  2.31. What is the ratio of the Exports (% of total merchandise exports) of Syrian Arab Republic in 2004 to that in 2008?
Provide a short and direct response. 2.54. What is the ratio of the Exports (% of total merchandise exports) of Bahamas in 2004 to that in 2009?
Offer a very short reply. 0.3. What is the ratio of the Exports (% of total merchandise exports) of El Salvador in 2004 to that in 2009?
Your answer should be very brief. 2.4. What is the ratio of the Exports (% of total merchandise exports) in Syrian Arab Republic in 2004 to that in 2009?
Your response must be concise. 4.34. What is the ratio of the Exports (% of total merchandise exports) in Bahamas in 2005 to that in 2006?
Offer a terse response. 1.4. What is the ratio of the Exports (% of total merchandise exports) of El Salvador in 2005 to that in 2006?
Give a very brief answer. 26.35. What is the ratio of the Exports (% of total merchandise exports) of Syrian Arab Republic in 2005 to that in 2006?
Your answer should be compact. 1.5. What is the ratio of the Exports (% of total merchandise exports) in Bahamas in 2005 to that in 2007?
Your response must be concise. 1.72. What is the ratio of the Exports (% of total merchandise exports) of El Salvador in 2005 to that in 2007?
Keep it short and to the point. 1.43. What is the ratio of the Exports (% of total merchandise exports) of Bahamas in 2005 to that in 2008?
Your response must be concise. 0.12. What is the ratio of the Exports (% of total merchandise exports) in El Salvador in 2005 to that in 2008?
Your answer should be very brief. 2.61. What is the ratio of the Exports (% of total merchandise exports) in Syrian Arab Republic in 2005 to that in 2008?
Keep it short and to the point. 0.66. What is the ratio of the Exports (% of total merchandise exports) of Bahamas in 2005 to that in 2009?
Provide a short and direct response. 0.72. What is the ratio of the Exports (% of total merchandise exports) of El Salvador in 2005 to that in 2009?
Ensure brevity in your answer.  2.72. What is the ratio of the Exports (% of total merchandise exports) of Syrian Arab Republic in 2005 to that in 2009?
Give a very brief answer. 1.13. What is the ratio of the Exports (% of total merchandise exports) in Bahamas in 2006 to that in 2007?
Your response must be concise. 1.23. What is the ratio of the Exports (% of total merchandise exports) of El Salvador in 2006 to that in 2007?
Give a very brief answer. 0.05. What is the ratio of the Exports (% of total merchandise exports) of Syrian Arab Republic in 2006 to that in 2007?
Your response must be concise. 0.66. What is the ratio of the Exports (% of total merchandise exports) in Bahamas in 2006 to that in 2008?
Ensure brevity in your answer.  0.08. What is the ratio of the Exports (% of total merchandise exports) in El Salvador in 2006 to that in 2008?
Your answer should be compact. 0.1. What is the ratio of the Exports (% of total merchandise exports) in Syrian Arab Republic in 2006 to that in 2008?
Your answer should be compact. 0.44. What is the ratio of the Exports (% of total merchandise exports) in Bahamas in 2006 to that in 2009?
Offer a very short reply. 0.51. What is the ratio of the Exports (% of total merchandise exports) in El Salvador in 2006 to that in 2009?
Your response must be concise. 0.1. What is the ratio of the Exports (% of total merchandise exports) of Syrian Arab Republic in 2006 to that in 2009?
Your response must be concise. 0.75. What is the ratio of the Exports (% of total merchandise exports) in Bahamas in 2007 to that in 2008?
Keep it short and to the point. 0.07. What is the ratio of the Exports (% of total merchandise exports) of El Salvador in 2007 to that in 2008?
Ensure brevity in your answer.  1.83. What is the ratio of the Exports (% of total merchandise exports) in Syrian Arab Republic in 2007 to that in 2008?
Make the answer very short. 0.67. What is the ratio of the Exports (% of total merchandise exports) in Bahamas in 2007 to that in 2009?
Provide a short and direct response. 0.42. What is the ratio of the Exports (% of total merchandise exports) of El Salvador in 2007 to that in 2009?
Your answer should be very brief. 1.9. What is the ratio of the Exports (% of total merchandise exports) in Syrian Arab Republic in 2007 to that in 2009?
Your response must be concise. 1.14. What is the ratio of the Exports (% of total merchandise exports) in Bahamas in 2008 to that in 2009?
Give a very brief answer. 6.17. What is the ratio of the Exports (% of total merchandise exports) in El Salvador in 2008 to that in 2009?
Provide a succinct answer. 1.04. What is the ratio of the Exports (% of total merchandise exports) in Syrian Arab Republic in 2008 to that in 2009?
Give a very brief answer. 1.71. What is the difference between the highest and the second highest Exports (% of total merchandise exports) of Bahamas?
Give a very brief answer. 1.38. What is the difference between the highest and the second highest Exports (% of total merchandise exports) in El Salvador?
Your answer should be very brief. 0. What is the difference between the highest and the second highest Exports (% of total merchandise exports) of Syrian Arab Republic?
Your answer should be compact. 4.95. What is the difference between the highest and the lowest Exports (% of total merchandise exports) of Bahamas?
Provide a succinct answer. 1.84. What is the difference between the highest and the lowest Exports (% of total merchandise exports) of El Salvador?
Give a very brief answer. 0.01. What is the difference between the highest and the lowest Exports (% of total merchandise exports) of Syrian Arab Republic?
Make the answer very short. 11.05. 